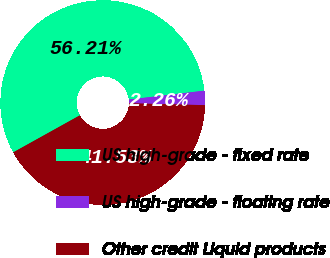Convert chart to OTSL. <chart><loc_0><loc_0><loc_500><loc_500><pie_chart><fcel>US high-grade - fixed rate<fcel>US high-grade - floating rate<fcel>Other credit Liquid products<nl><fcel>56.21%<fcel>2.26%<fcel>41.53%<nl></chart> 